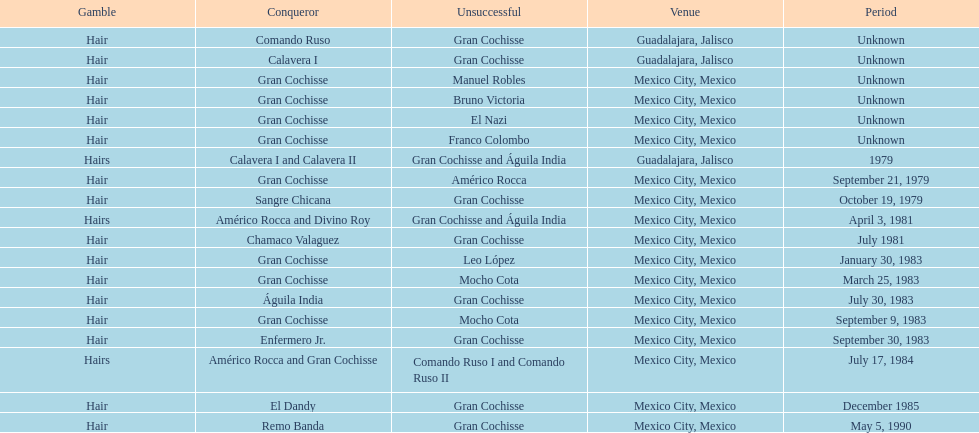What was the number of losses gran cochisse had against el dandy? 1. 